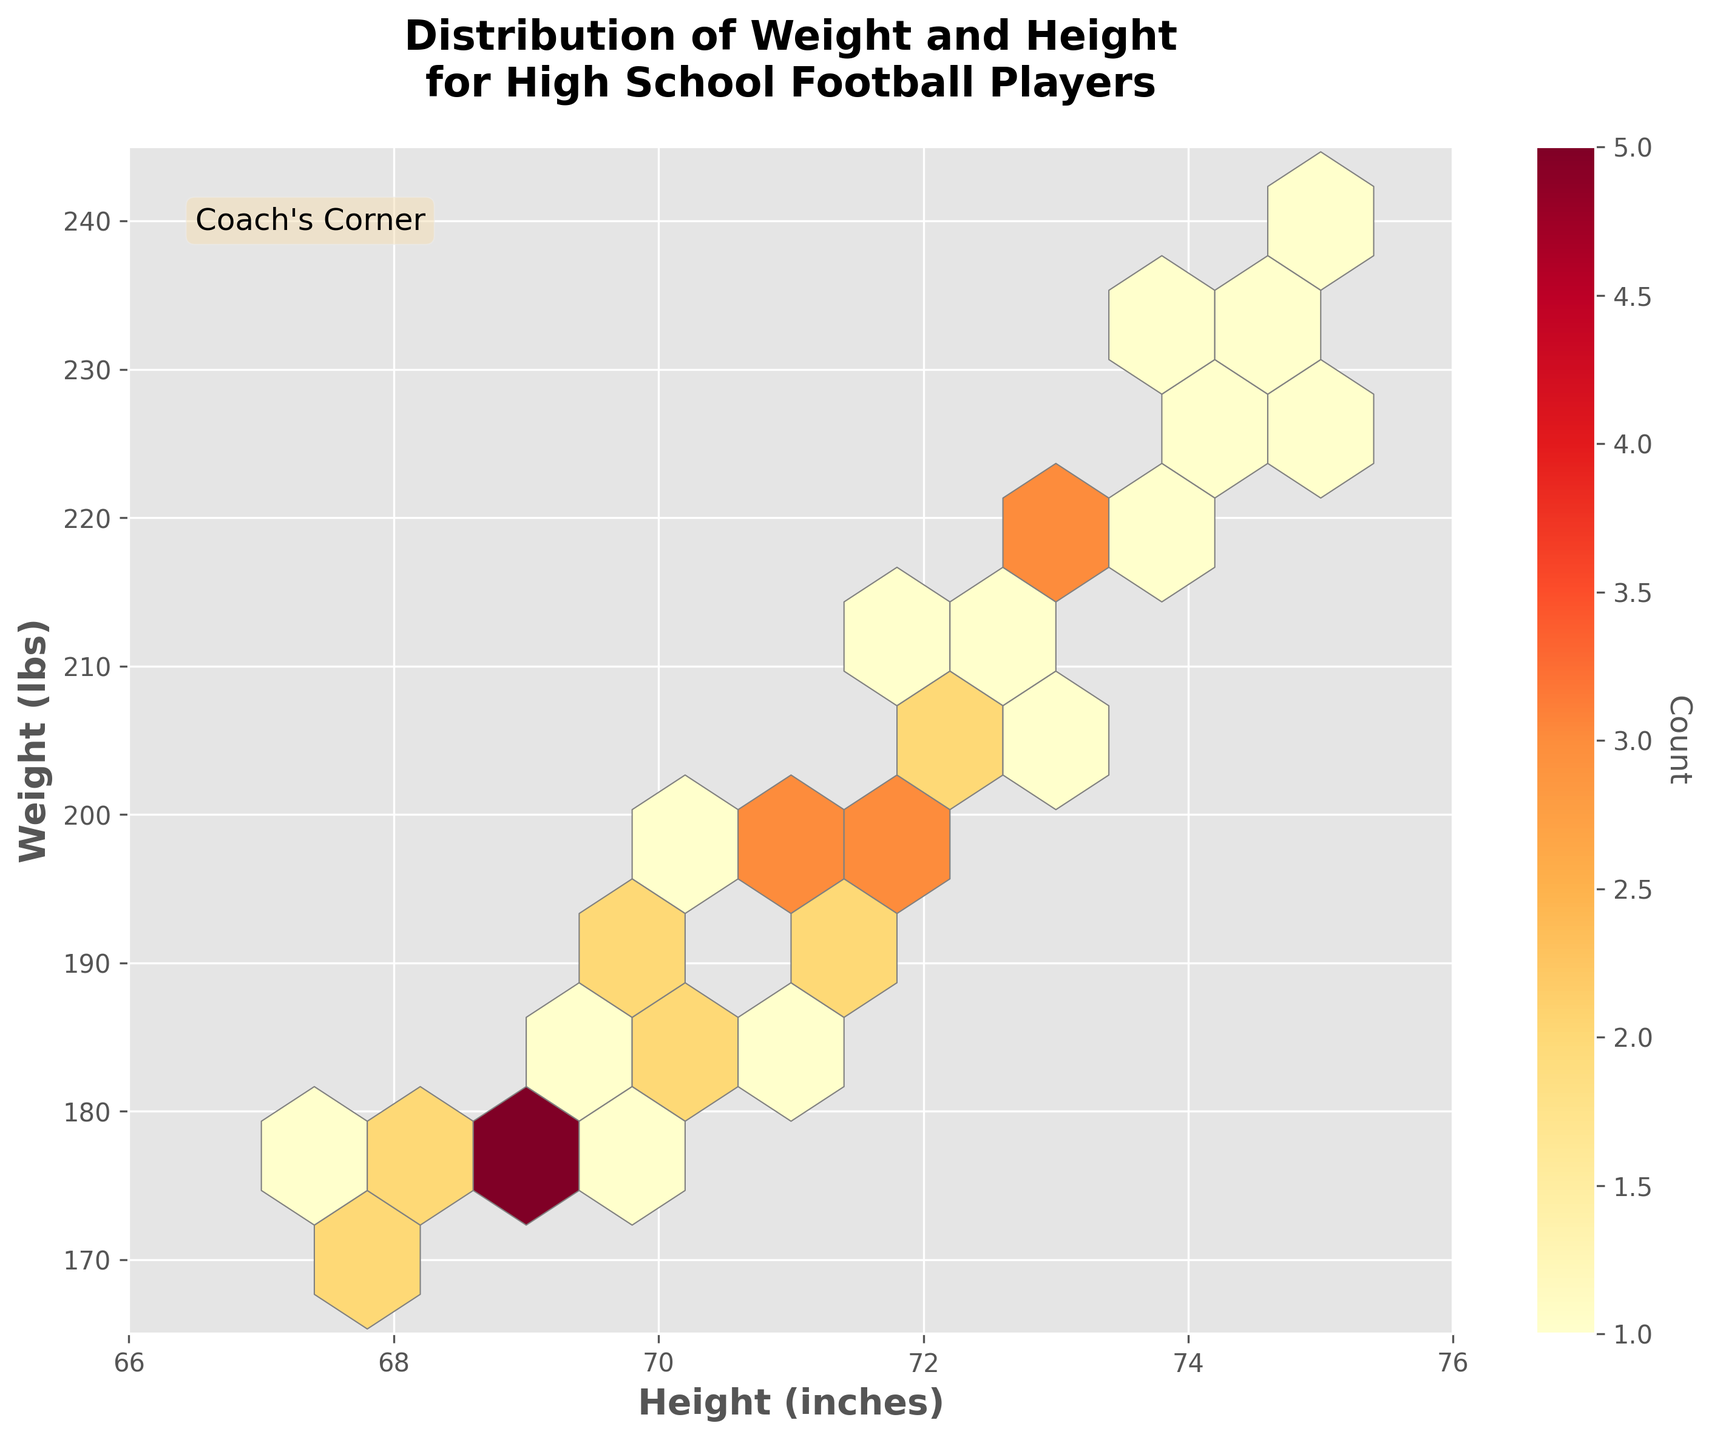What is the title of the figure? The title of the figure is located at the top center and it summarizes the main topic of the plot.
Answer: Distribution of Weight and Height for High School Football Players What are the axes labels in the figure? The axes labels indicate what each axis represents. The x-axis label is at the bottom and the y-axis label is on the left side of the plot.
Answer: Height (inches) and Weight (lbs) Which hexbin color indicates the highest density of points? The hexbin plot uses a color gradient to show density, with colors closer to red or dark orange indicating higher densities.
Answer: Dark orange or red Within which height range do most players fall? The height axis is on the x-axis, and most players can be found within the densest cluster of hexagons around the middle of this axis.
Answer: 68 to 73 inches What is the height and weight range on the axes? The figure's axes encompass values where the data points are plotted. The x-axis ranges from about 66 to 76 inches and the y-axis ranges from about 165 to 245 lbs.
Answer: Height: 66 to 76 inches, Weight: 165 to 245 lbs How many players are at the highest density point? The color bar on the right of the figure helps in determining the count at the highest density. The darkest color corresponds to the highest count.
Answer: 3 players Is there a higher density of players around 70 inches and 190 lbs or around 74 inches and 230 lbs? Observing the hexbin plot and the density colors will show which region has denser hexagons.
Answer: 70 inches and 190 lbs Which height group, 68-70 inches or 73-75 inches, tends to have heavier players on average? By examining the hexbin plot, we can see the weight distribution within these height ranges by looking at the y-axis values of their densest areas.
Answer: 73-75 inches Are there more players weighing around 200 lbs or around 180 lbs? Comparing the density of hexagons near these weight values will show which is higher.
Answer: Around 200 lbs Which range shows the least density in the figure? The least dense areas have lighter colors or fewer hexagons. The white or lightest yellow hexagons generally indicate lower density regions.
Answer: Near 66-67 inches and 165-175 lbs 